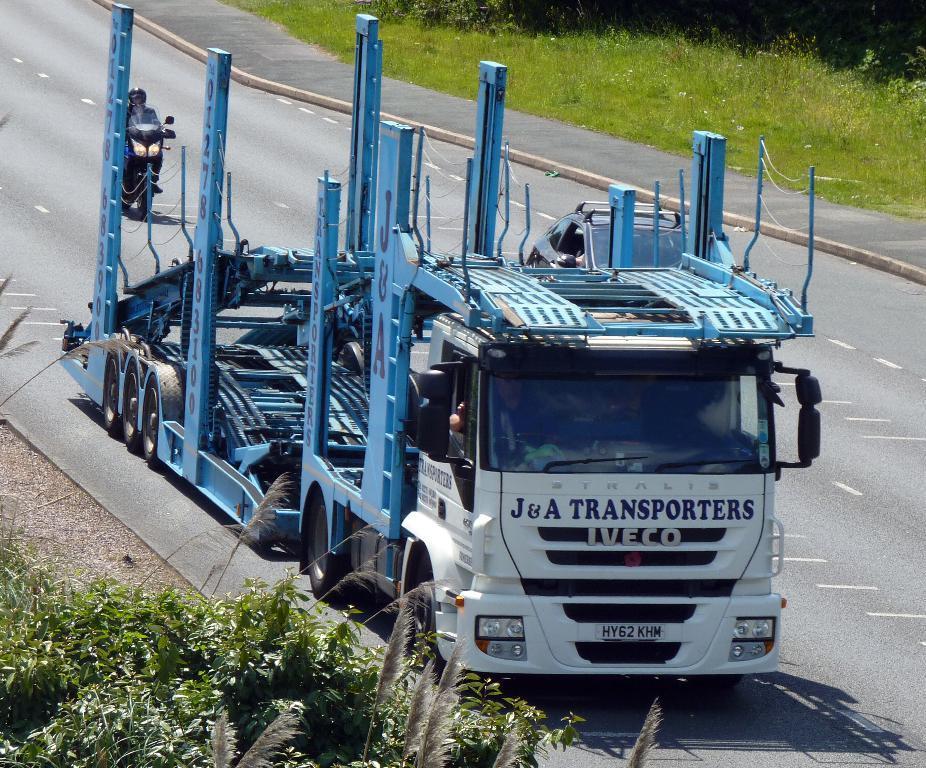Can you describe this image briefly? In this image I can see a vehicle which is white, blue and black in color on the road. I can see a person in the vehicle, another car and a person riding a motorbike on the road. I can see some grass and few trees on both sides of the road. 